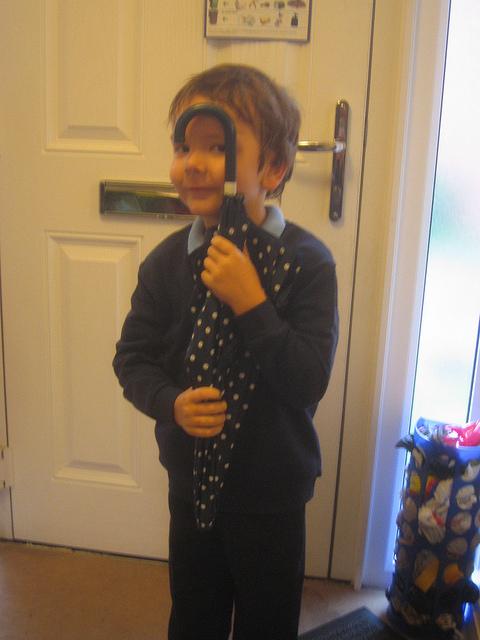What game are they playing?
Short answer required. Peekaboo. What is the child holding?
Quick response, please. Umbrella. Why does the door have a brass covered hole in it?
Write a very short answer. Mail slot. Where is the door knocker?
Concise answer only. Outside. What is the horizontal metal bar in the door for?
Write a very short answer. Mail. 